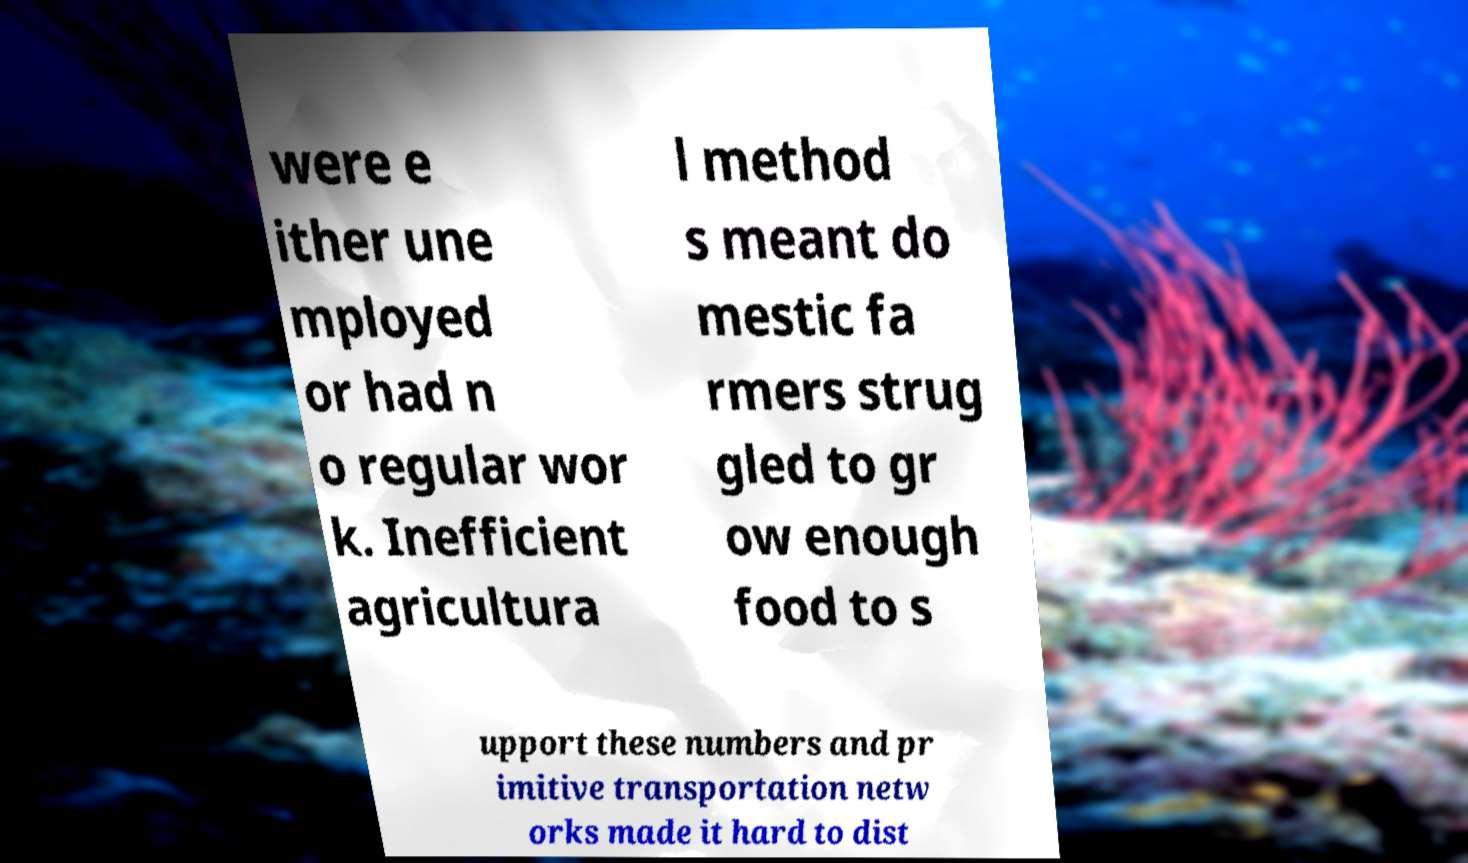Can you read and provide the text displayed in the image?This photo seems to have some interesting text. Can you extract and type it out for me? were e ither une mployed or had n o regular wor k. Inefficient agricultura l method s meant do mestic fa rmers strug gled to gr ow enough food to s upport these numbers and pr imitive transportation netw orks made it hard to dist 